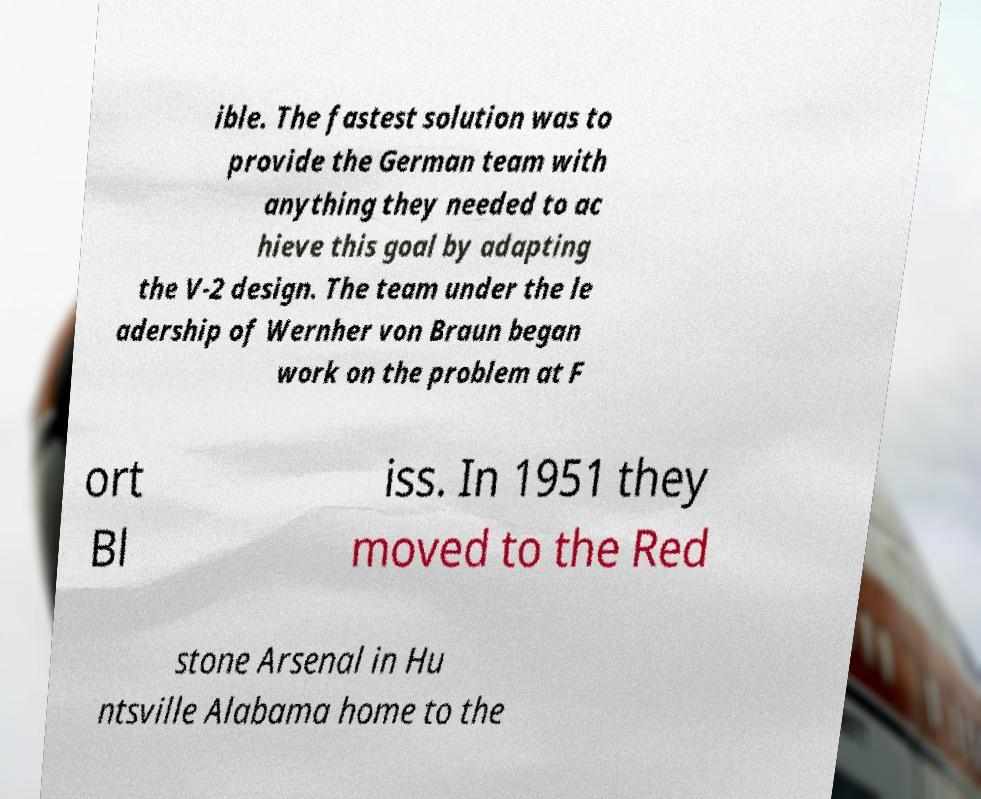Can you read and provide the text displayed in the image?This photo seems to have some interesting text. Can you extract and type it out for me? ible. The fastest solution was to provide the German team with anything they needed to ac hieve this goal by adapting the V-2 design. The team under the le adership of Wernher von Braun began work on the problem at F ort Bl iss. In 1951 they moved to the Red stone Arsenal in Hu ntsville Alabama home to the 